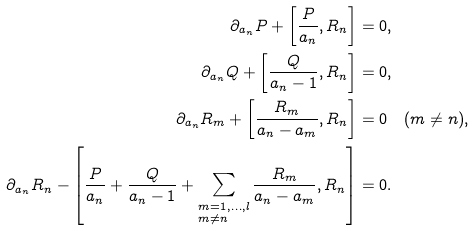<formula> <loc_0><loc_0><loc_500><loc_500>\partial _ { a _ { n } } P + \left [ \frac { P } { a _ { n } } , R _ { n } \right ] & = 0 , \\ \partial _ { a _ { n } } Q + \left [ \frac { Q } { a _ { n } - 1 } , R _ { n } \right ] & = 0 , \\ \partial _ { a _ { n } } R _ { m } + \left [ \frac { R _ { m } } { a _ { n } - a _ { m } } , R _ { n } \right ] & = 0 \quad ( m \ne n ) , \\ \partial _ { a _ { n } } R _ { n } - \left [ \frac { P } { a _ { n } } + \frac { Q } { a _ { n } - 1 } + \sum _ { \begin{subarray} { c } m = 1 , \dots , l \\ m \ne n \end{subarray} } \frac { R _ { m } } { a _ { n } - a _ { m } } , R _ { n } \right ] & = 0 .</formula> 